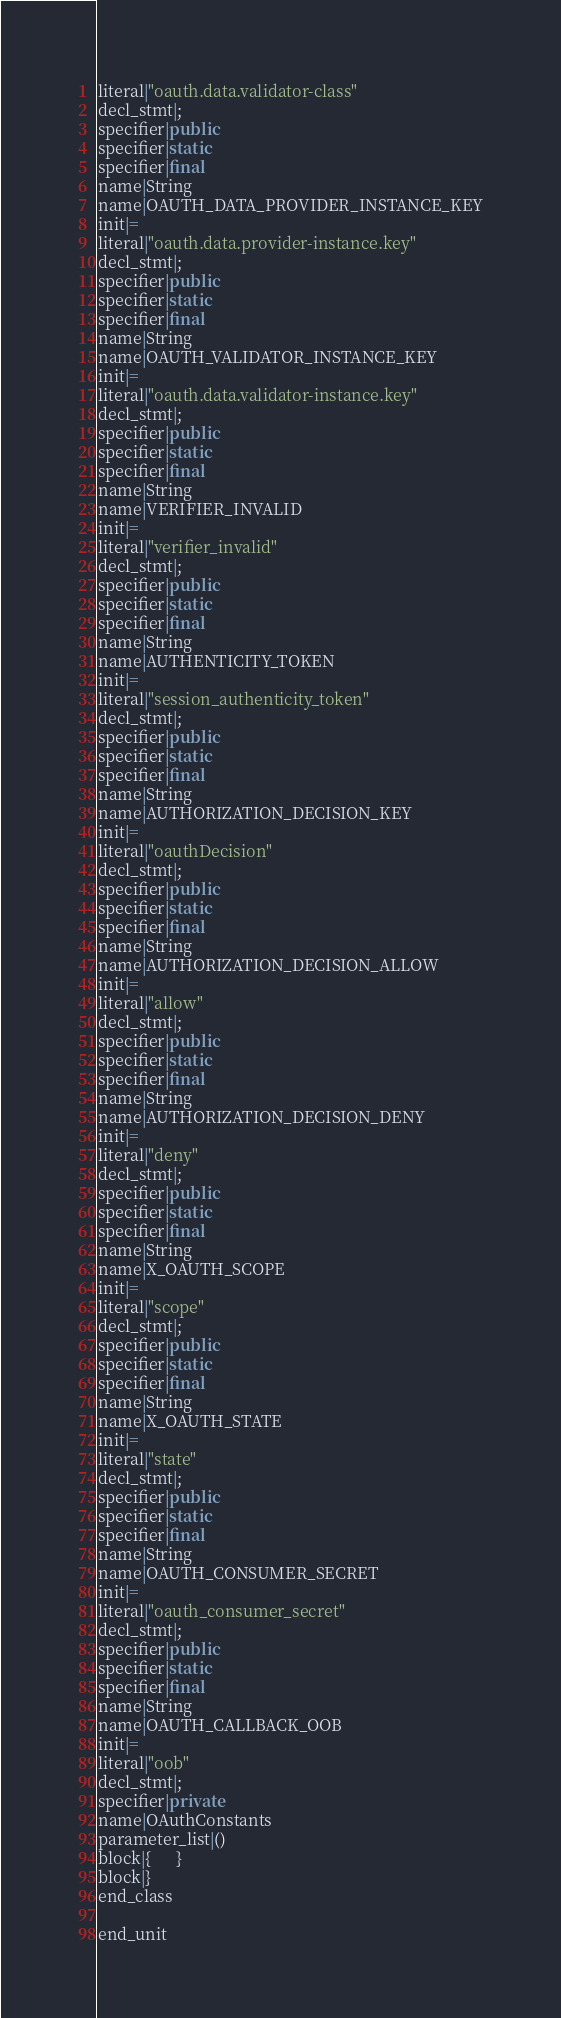<code> <loc_0><loc_0><loc_500><loc_500><_Java_>literal|"oauth.data.validator-class"
decl_stmt|;
specifier|public
specifier|static
specifier|final
name|String
name|OAUTH_DATA_PROVIDER_INSTANCE_KEY
init|=
literal|"oauth.data.provider-instance.key"
decl_stmt|;
specifier|public
specifier|static
specifier|final
name|String
name|OAUTH_VALIDATOR_INSTANCE_KEY
init|=
literal|"oauth.data.validator-instance.key"
decl_stmt|;
specifier|public
specifier|static
specifier|final
name|String
name|VERIFIER_INVALID
init|=
literal|"verifier_invalid"
decl_stmt|;
specifier|public
specifier|static
specifier|final
name|String
name|AUTHENTICITY_TOKEN
init|=
literal|"session_authenticity_token"
decl_stmt|;
specifier|public
specifier|static
specifier|final
name|String
name|AUTHORIZATION_DECISION_KEY
init|=
literal|"oauthDecision"
decl_stmt|;
specifier|public
specifier|static
specifier|final
name|String
name|AUTHORIZATION_DECISION_ALLOW
init|=
literal|"allow"
decl_stmt|;
specifier|public
specifier|static
specifier|final
name|String
name|AUTHORIZATION_DECISION_DENY
init|=
literal|"deny"
decl_stmt|;
specifier|public
specifier|static
specifier|final
name|String
name|X_OAUTH_SCOPE
init|=
literal|"scope"
decl_stmt|;
specifier|public
specifier|static
specifier|final
name|String
name|X_OAUTH_STATE
init|=
literal|"state"
decl_stmt|;
specifier|public
specifier|static
specifier|final
name|String
name|OAUTH_CONSUMER_SECRET
init|=
literal|"oauth_consumer_secret"
decl_stmt|;
specifier|public
specifier|static
specifier|final
name|String
name|OAUTH_CALLBACK_OOB
init|=
literal|"oob"
decl_stmt|;
specifier|private
name|OAuthConstants
parameter_list|()
block|{      }
block|}
end_class

end_unit

</code> 